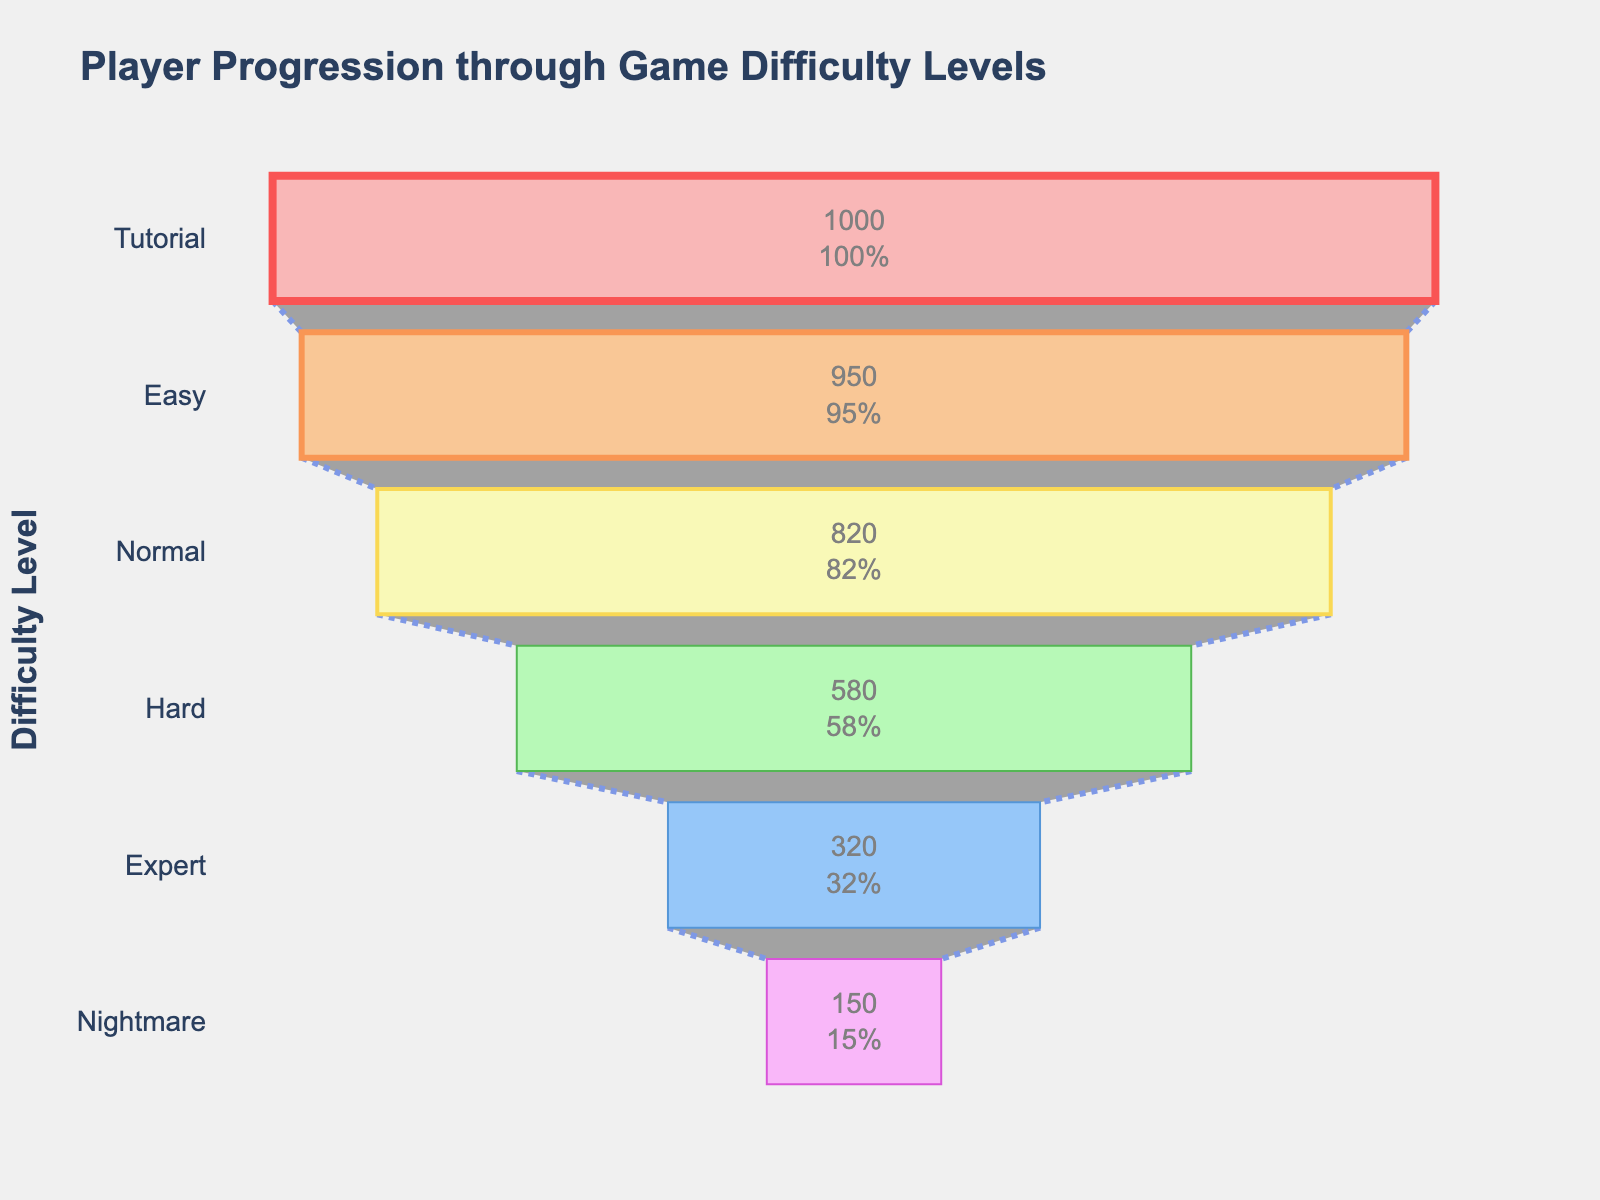What's the title of the chart? The title is displayed prominently at the top of the chart. It provides an overview of what the chart represents.
Answer: Player Progression through Game Difficulty Levels How many players reached the Easy level? The number of players for each level is shown inside the corresponding section of the funnel. Look for the value inside the section labeled "Easy".
Answer: 950 Among the levels presented, which one retained the highest percentage of players from the previous level? Calculate the percentage of players retained from the previous level for each transition and compare them. Highest percentage indicates best retention.
Answer: Easy (95%) Which level has the smallest number of players reaching it? Identify the section on the funnel chart with the smallest value displayed inside it.
Answer: Nightmare Which color represents the Hard level? Identify the unique color associated with the Hard level section in the funnel chart.
Answer: Light Green How does the player count at the Normal level compare to that at the Nightmare level? Compare the player counts of the Normal and Nightmare levels to identify which is higher.
Answer: Normal has more players than Nightmare What is the overall trend in player progression as difficulty increases? Interpret the funnel chart to observe whether the number of players increases, decreases, or remains constant as difficulty levels increase.
Answer: The number of players decreases 